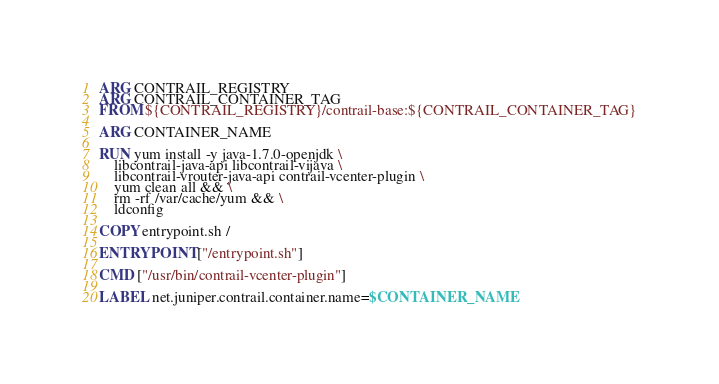Convert code to text. <code><loc_0><loc_0><loc_500><loc_500><_Dockerfile_>ARG CONTRAIL_REGISTRY
ARG CONTRAIL_CONTAINER_TAG
FROM ${CONTRAIL_REGISTRY}/contrail-base:${CONTRAIL_CONTAINER_TAG}

ARG CONTAINER_NAME

RUN yum install -y java-1.7.0-openjdk \
    libcontrail-java-api libcontrail-vijava \
    libcontrail-vrouter-java-api contrail-vcenter-plugin \
    yum clean all && \
    rm -rf /var/cache/yum && \
    ldconfig

COPY entrypoint.sh /

ENTRYPOINT ["/entrypoint.sh"]

CMD ["/usr/bin/contrail-vcenter-plugin"]

LABEL net.juniper.contrail.container.name=$CONTAINER_NAME
</code> 